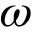<formula> <loc_0><loc_0><loc_500><loc_500>\omega</formula> 